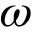<formula> <loc_0><loc_0><loc_500><loc_500>\omega</formula> 